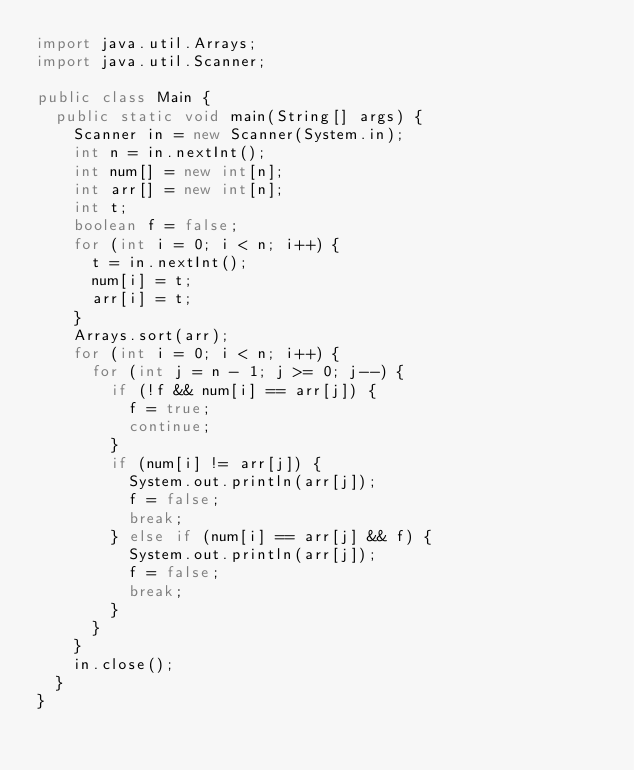Convert code to text. <code><loc_0><loc_0><loc_500><loc_500><_Java_>import java.util.Arrays;
import java.util.Scanner;

public class Main {
	public static void main(String[] args) {
		Scanner in = new Scanner(System.in);
		int n = in.nextInt();
		int num[] = new int[n];
		int arr[] = new int[n];
		int t;
		boolean f = false;
		for (int i = 0; i < n; i++) {
			t = in.nextInt();
			num[i] = t;
			arr[i] = t;
		}
		Arrays.sort(arr);
		for (int i = 0; i < n; i++) {
			for (int j = n - 1; j >= 0; j--) {
				if (!f && num[i] == arr[j]) {
					f = true;
					continue;
				}
				if (num[i] != arr[j]) {
					System.out.println(arr[j]);
					f = false;
					break;
				} else if (num[i] == arr[j] && f) {
					System.out.println(arr[j]);
					f = false;
					break;
				}
			}
		}
		in.close();
	}
}
</code> 